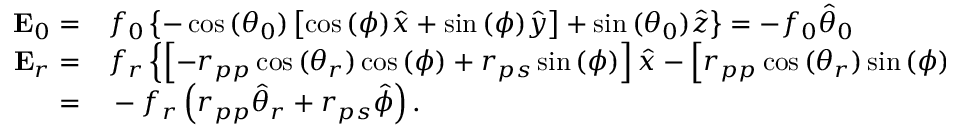Convert formula to latex. <formula><loc_0><loc_0><loc_500><loc_500>\begin{array} { r l } { E _ { 0 } = } & f _ { 0 } \left \{ - \cos { ( \theta _ { 0 } ) } \left [ \cos { ( \phi ) } \hat { x } + \sin { ( \phi ) } \hat { y } \right ] + \sin { ( \theta _ { 0 } ) } \hat { z } \right \} = - f _ { 0 } \hat { \theta } _ { 0 } } \\ { E _ { r } = } & f _ { r } \left \{ \left [ - r _ { p p } \cos { ( \theta _ { r } ) } \cos { ( \phi ) } + r _ { p s } \sin { ( \phi ) } \right ] \hat { x } - \left [ r _ { p p } \cos { ( \theta _ { r } ) } \sin { ( \phi ) } + r _ { p s } \cos { ( \phi ) } \right ] \hat { y } + r _ { p p } \sin { ( \theta _ { r } ) } \hat { z } \right \} } \\ { = } & - f _ { r } \left ( r _ { p p } \hat { \theta } _ { r } + r _ { p s } \hat { \phi } \right ) . } \end{array}</formula> 